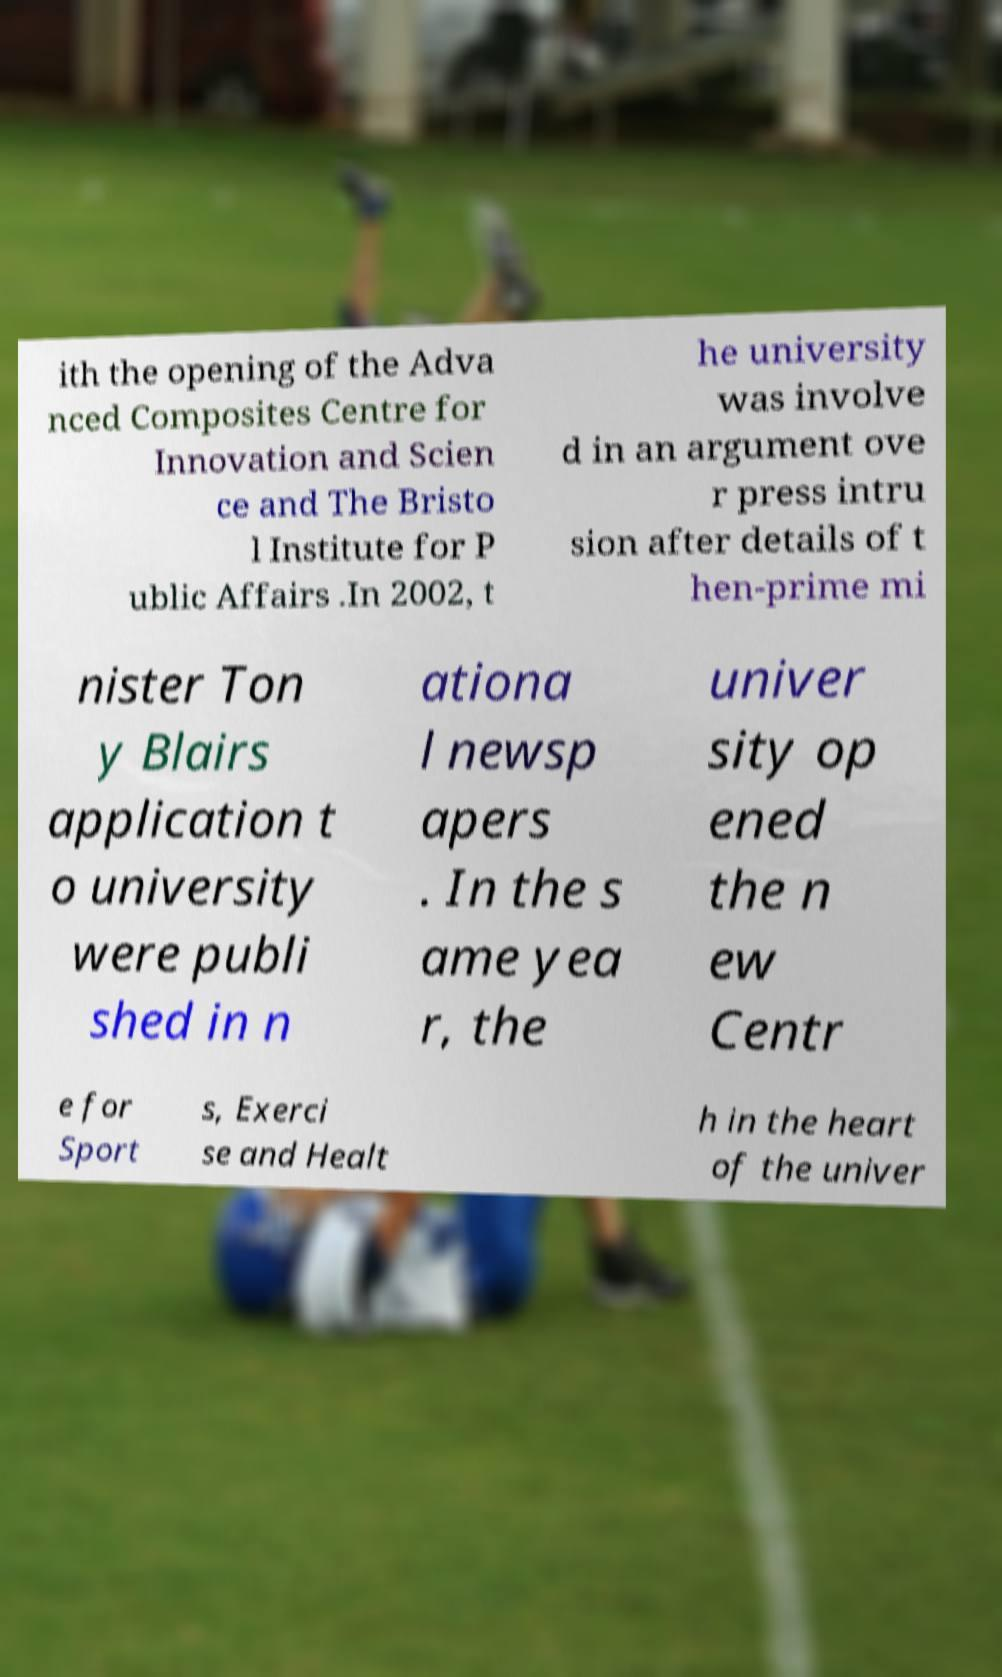What messages or text are displayed in this image? I need them in a readable, typed format. ith the opening of the Adva nced Composites Centre for Innovation and Scien ce and The Bristo l Institute for P ublic Affairs .In 2002, t he university was involve d in an argument ove r press intru sion after details of t hen-prime mi nister Ton y Blairs application t o university were publi shed in n ationa l newsp apers . In the s ame yea r, the univer sity op ened the n ew Centr e for Sport s, Exerci se and Healt h in the heart of the univer 